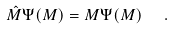<formula> <loc_0><loc_0><loc_500><loc_500>\hat { M } \Psi ( M ) = M \Psi ( M ) \ \ .</formula> 